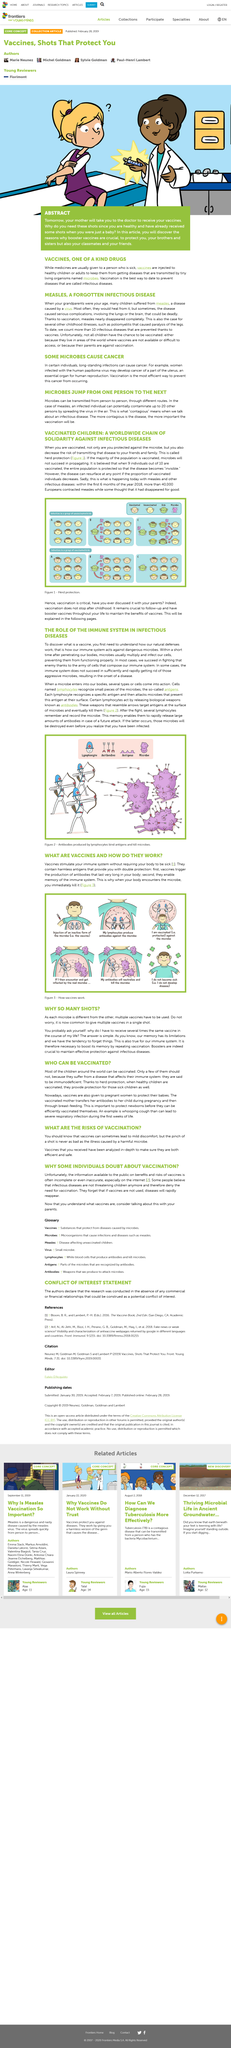Specify some key components in this picture. Vaccines stimulate the immune system by triggering the production of antibodies, without causing the body to become sick. Your body kills microbes as stated in the article. The lymphocytes in the immune system are responsible for recording and remembering microbes, allowing them to mount an effective response to future encounters with the same microbe. Lymphocytes are immune cells that are responsible for releasing antibodies in response to an infection or foreign substance. Microbes are known to multiply and infect human cells. 